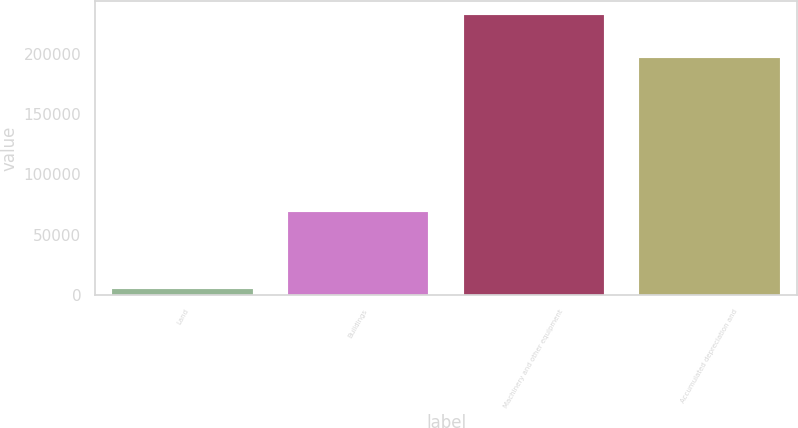Convert chart. <chart><loc_0><loc_0><loc_500><loc_500><bar_chart><fcel>Land<fcel>Buildings<fcel>Machinery and other equipment<fcel>Accumulated depreciation and<nl><fcel>5068<fcel>68912<fcel>231768<fcel>196255<nl></chart> 